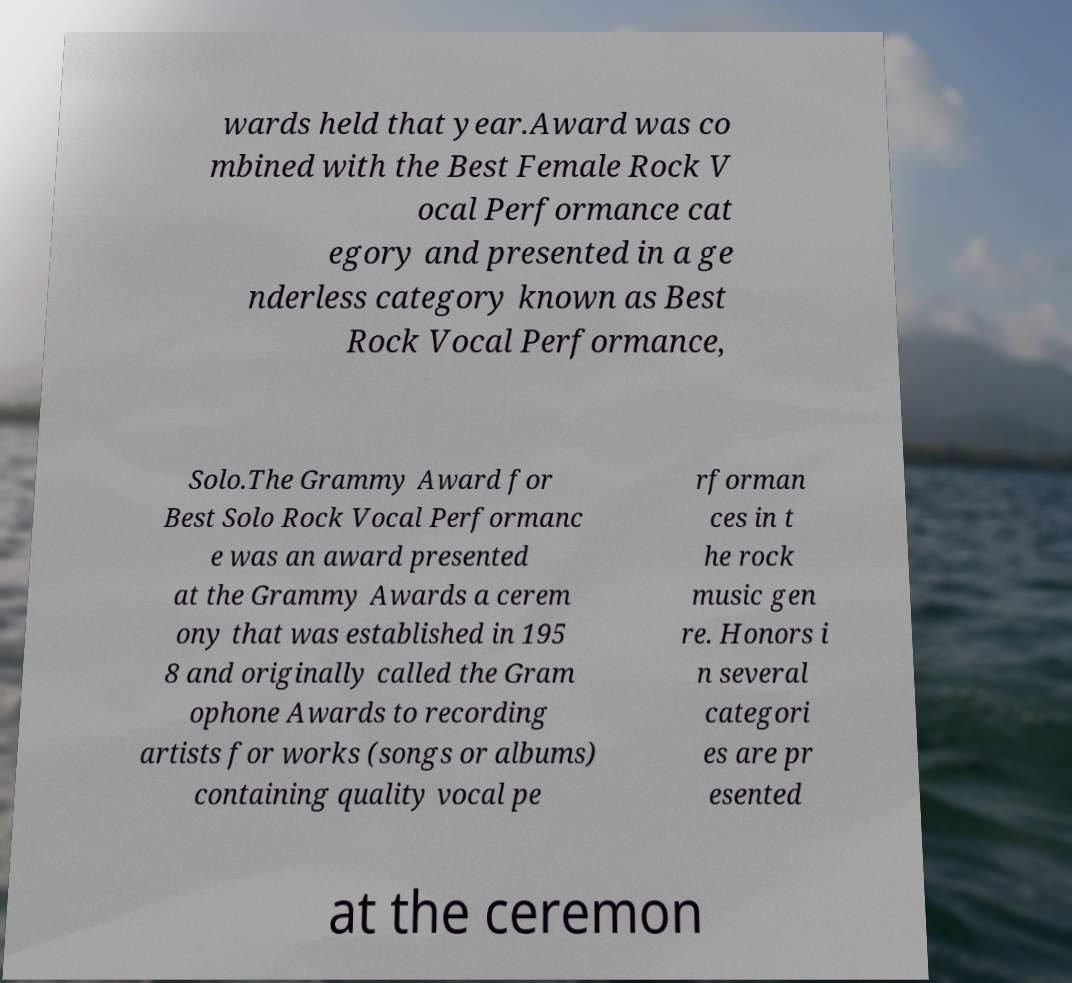What messages or text are displayed in this image? I need them in a readable, typed format. wards held that year.Award was co mbined with the Best Female Rock V ocal Performance cat egory and presented in a ge nderless category known as Best Rock Vocal Performance, Solo.The Grammy Award for Best Solo Rock Vocal Performanc e was an award presented at the Grammy Awards a cerem ony that was established in 195 8 and originally called the Gram ophone Awards to recording artists for works (songs or albums) containing quality vocal pe rforman ces in t he rock music gen re. Honors i n several categori es are pr esented at the ceremon 